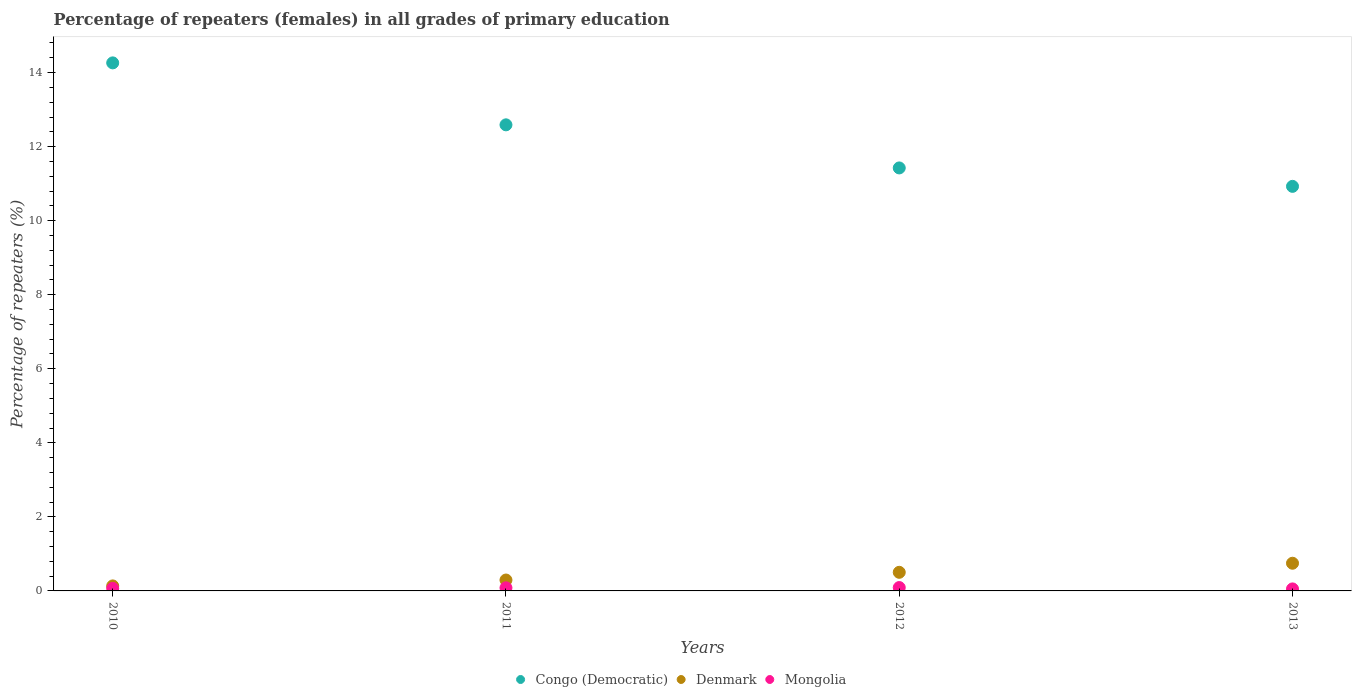Is the number of dotlines equal to the number of legend labels?
Offer a terse response. Yes. What is the percentage of repeaters (females) in Congo (Democratic) in 2011?
Your response must be concise. 12.59. Across all years, what is the maximum percentage of repeaters (females) in Mongolia?
Offer a very short reply. 0.09. Across all years, what is the minimum percentage of repeaters (females) in Mongolia?
Your answer should be compact. 0.05. In which year was the percentage of repeaters (females) in Denmark maximum?
Your answer should be very brief. 2013. What is the total percentage of repeaters (females) in Denmark in the graph?
Ensure brevity in your answer.  1.68. What is the difference between the percentage of repeaters (females) in Mongolia in 2012 and that in 2013?
Ensure brevity in your answer.  0.04. What is the difference between the percentage of repeaters (females) in Denmark in 2011 and the percentage of repeaters (females) in Mongolia in 2012?
Keep it short and to the point. 0.2. What is the average percentage of repeaters (females) in Mongolia per year?
Give a very brief answer. 0.07. In the year 2011, what is the difference between the percentage of repeaters (females) in Mongolia and percentage of repeaters (females) in Denmark?
Your answer should be compact. -0.21. What is the ratio of the percentage of repeaters (females) in Denmark in 2012 to that in 2013?
Give a very brief answer. 0.67. Is the percentage of repeaters (females) in Denmark in 2012 less than that in 2013?
Make the answer very short. Yes. Is the difference between the percentage of repeaters (females) in Mongolia in 2010 and 2013 greater than the difference between the percentage of repeaters (females) in Denmark in 2010 and 2013?
Your answer should be very brief. Yes. What is the difference between the highest and the second highest percentage of repeaters (females) in Mongolia?
Keep it short and to the point. 0.01. What is the difference between the highest and the lowest percentage of repeaters (females) in Mongolia?
Give a very brief answer. 0.04. Is the sum of the percentage of repeaters (females) in Denmark in 2010 and 2011 greater than the maximum percentage of repeaters (females) in Congo (Democratic) across all years?
Your answer should be very brief. No. Is it the case that in every year, the sum of the percentage of repeaters (females) in Denmark and percentage of repeaters (females) in Congo (Democratic)  is greater than the percentage of repeaters (females) in Mongolia?
Provide a succinct answer. Yes. Does the percentage of repeaters (females) in Mongolia monotonically increase over the years?
Provide a succinct answer. No. Is the percentage of repeaters (females) in Congo (Democratic) strictly less than the percentage of repeaters (females) in Mongolia over the years?
Your response must be concise. No. How many years are there in the graph?
Offer a terse response. 4. Are the values on the major ticks of Y-axis written in scientific E-notation?
Give a very brief answer. No. Does the graph contain grids?
Your response must be concise. No. How many legend labels are there?
Provide a succinct answer. 3. How are the legend labels stacked?
Your answer should be very brief. Horizontal. What is the title of the graph?
Offer a very short reply. Percentage of repeaters (females) in all grades of primary education. Does "Panama" appear as one of the legend labels in the graph?
Ensure brevity in your answer.  No. What is the label or title of the Y-axis?
Keep it short and to the point. Percentage of repeaters (%). What is the Percentage of repeaters (%) of Congo (Democratic) in 2010?
Your answer should be compact. 14.26. What is the Percentage of repeaters (%) in Denmark in 2010?
Provide a succinct answer. 0.14. What is the Percentage of repeaters (%) of Mongolia in 2010?
Provide a short and direct response. 0.07. What is the Percentage of repeaters (%) in Congo (Democratic) in 2011?
Your answer should be compact. 12.59. What is the Percentage of repeaters (%) of Denmark in 2011?
Offer a very short reply. 0.29. What is the Percentage of repeaters (%) of Mongolia in 2011?
Your answer should be very brief. 0.08. What is the Percentage of repeaters (%) in Congo (Democratic) in 2012?
Keep it short and to the point. 11.43. What is the Percentage of repeaters (%) in Denmark in 2012?
Keep it short and to the point. 0.5. What is the Percentage of repeaters (%) of Mongolia in 2012?
Your answer should be compact. 0.09. What is the Percentage of repeaters (%) in Congo (Democratic) in 2013?
Your answer should be compact. 10.93. What is the Percentage of repeaters (%) in Denmark in 2013?
Ensure brevity in your answer.  0.75. What is the Percentage of repeaters (%) of Mongolia in 2013?
Make the answer very short. 0.05. Across all years, what is the maximum Percentage of repeaters (%) in Congo (Democratic)?
Your answer should be very brief. 14.26. Across all years, what is the maximum Percentage of repeaters (%) of Denmark?
Ensure brevity in your answer.  0.75. Across all years, what is the maximum Percentage of repeaters (%) of Mongolia?
Offer a very short reply. 0.09. Across all years, what is the minimum Percentage of repeaters (%) in Congo (Democratic)?
Provide a short and direct response. 10.93. Across all years, what is the minimum Percentage of repeaters (%) in Denmark?
Provide a succinct answer. 0.14. Across all years, what is the minimum Percentage of repeaters (%) in Mongolia?
Your response must be concise. 0.05. What is the total Percentage of repeaters (%) in Congo (Democratic) in the graph?
Give a very brief answer. 49.21. What is the total Percentage of repeaters (%) of Denmark in the graph?
Keep it short and to the point. 1.68. What is the total Percentage of repeaters (%) in Mongolia in the graph?
Make the answer very short. 0.3. What is the difference between the Percentage of repeaters (%) in Congo (Democratic) in 2010 and that in 2011?
Provide a short and direct response. 1.67. What is the difference between the Percentage of repeaters (%) in Denmark in 2010 and that in 2011?
Make the answer very short. -0.16. What is the difference between the Percentage of repeaters (%) of Mongolia in 2010 and that in 2011?
Make the answer very short. -0.02. What is the difference between the Percentage of repeaters (%) in Congo (Democratic) in 2010 and that in 2012?
Offer a terse response. 2.84. What is the difference between the Percentage of repeaters (%) of Denmark in 2010 and that in 2012?
Provide a short and direct response. -0.37. What is the difference between the Percentage of repeaters (%) in Mongolia in 2010 and that in 2012?
Ensure brevity in your answer.  -0.02. What is the difference between the Percentage of repeaters (%) in Congo (Democratic) in 2010 and that in 2013?
Your response must be concise. 3.34. What is the difference between the Percentage of repeaters (%) of Denmark in 2010 and that in 2013?
Your answer should be very brief. -0.61. What is the difference between the Percentage of repeaters (%) of Mongolia in 2010 and that in 2013?
Offer a very short reply. 0.01. What is the difference between the Percentage of repeaters (%) in Congo (Democratic) in 2011 and that in 2012?
Offer a terse response. 1.16. What is the difference between the Percentage of repeaters (%) of Denmark in 2011 and that in 2012?
Give a very brief answer. -0.21. What is the difference between the Percentage of repeaters (%) of Mongolia in 2011 and that in 2012?
Make the answer very short. -0.01. What is the difference between the Percentage of repeaters (%) of Congo (Democratic) in 2011 and that in 2013?
Your answer should be compact. 1.66. What is the difference between the Percentage of repeaters (%) in Denmark in 2011 and that in 2013?
Your answer should be very brief. -0.45. What is the difference between the Percentage of repeaters (%) of Mongolia in 2011 and that in 2013?
Offer a very short reply. 0.03. What is the difference between the Percentage of repeaters (%) of Congo (Democratic) in 2012 and that in 2013?
Your response must be concise. 0.5. What is the difference between the Percentage of repeaters (%) in Denmark in 2012 and that in 2013?
Provide a short and direct response. -0.24. What is the difference between the Percentage of repeaters (%) in Mongolia in 2012 and that in 2013?
Your response must be concise. 0.04. What is the difference between the Percentage of repeaters (%) of Congo (Democratic) in 2010 and the Percentage of repeaters (%) of Denmark in 2011?
Give a very brief answer. 13.97. What is the difference between the Percentage of repeaters (%) of Congo (Democratic) in 2010 and the Percentage of repeaters (%) of Mongolia in 2011?
Give a very brief answer. 14.18. What is the difference between the Percentage of repeaters (%) of Denmark in 2010 and the Percentage of repeaters (%) of Mongolia in 2011?
Keep it short and to the point. 0.05. What is the difference between the Percentage of repeaters (%) in Congo (Democratic) in 2010 and the Percentage of repeaters (%) in Denmark in 2012?
Offer a terse response. 13.76. What is the difference between the Percentage of repeaters (%) of Congo (Democratic) in 2010 and the Percentage of repeaters (%) of Mongolia in 2012?
Ensure brevity in your answer.  14.17. What is the difference between the Percentage of repeaters (%) in Denmark in 2010 and the Percentage of repeaters (%) in Mongolia in 2012?
Your response must be concise. 0.04. What is the difference between the Percentage of repeaters (%) in Congo (Democratic) in 2010 and the Percentage of repeaters (%) in Denmark in 2013?
Your answer should be compact. 13.52. What is the difference between the Percentage of repeaters (%) of Congo (Democratic) in 2010 and the Percentage of repeaters (%) of Mongolia in 2013?
Your response must be concise. 14.21. What is the difference between the Percentage of repeaters (%) of Denmark in 2010 and the Percentage of repeaters (%) of Mongolia in 2013?
Your answer should be compact. 0.08. What is the difference between the Percentage of repeaters (%) in Congo (Democratic) in 2011 and the Percentage of repeaters (%) in Denmark in 2012?
Make the answer very short. 12.09. What is the difference between the Percentage of repeaters (%) in Congo (Democratic) in 2011 and the Percentage of repeaters (%) in Mongolia in 2012?
Your answer should be very brief. 12.5. What is the difference between the Percentage of repeaters (%) of Denmark in 2011 and the Percentage of repeaters (%) of Mongolia in 2012?
Your answer should be very brief. 0.2. What is the difference between the Percentage of repeaters (%) of Congo (Democratic) in 2011 and the Percentage of repeaters (%) of Denmark in 2013?
Offer a terse response. 11.84. What is the difference between the Percentage of repeaters (%) of Congo (Democratic) in 2011 and the Percentage of repeaters (%) of Mongolia in 2013?
Your answer should be very brief. 12.54. What is the difference between the Percentage of repeaters (%) of Denmark in 2011 and the Percentage of repeaters (%) of Mongolia in 2013?
Your response must be concise. 0.24. What is the difference between the Percentage of repeaters (%) in Congo (Democratic) in 2012 and the Percentage of repeaters (%) in Denmark in 2013?
Your answer should be very brief. 10.68. What is the difference between the Percentage of repeaters (%) in Congo (Democratic) in 2012 and the Percentage of repeaters (%) in Mongolia in 2013?
Keep it short and to the point. 11.37. What is the difference between the Percentage of repeaters (%) in Denmark in 2012 and the Percentage of repeaters (%) in Mongolia in 2013?
Your response must be concise. 0.45. What is the average Percentage of repeaters (%) of Congo (Democratic) per year?
Offer a very short reply. 12.3. What is the average Percentage of repeaters (%) of Denmark per year?
Keep it short and to the point. 0.42. What is the average Percentage of repeaters (%) in Mongolia per year?
Offer a very short reply. 0.07. In the year 2010, what is the difference between the Percentage of repeaters (%) in Congo (Democratic) and Percentage of repeaters (%) in Denmark?
Provide a succinct answer. 14.13. In the year 2010, what is the difference between the Percentage of repeaters (%) of Congo (Democratic) and Percentage of repeaters (%) of Mongolia?
Your answer should be very brief. 14.19. In the year 2010, what is the difference between the Percentage of repeaters (%) in Denmark and Percentage of repeaters (%) in Mongolia?
Keep it short and to the point. 0.07. In the year 2011, what is the difference between the Percentage of repeaters (%) in Congo (Democratic) and Percentage of repeaters (%) in Denmark?
Your answer should be very brief. 12.29. In the year 2011, what is the difference between the Percentage of repeaters (%) in Congo (Democratic) and Percentage of repeaters (%) in Mongolia?
Keep it short and to the point. 12.51. In the year 2011, what is the difference between the Percentage of repeaters (%) of Denmark and Percentage of repeaters (%) of Mongolia?
Your response must be concise. 0.21. In the year 2012, what is the difference between the Percentage of repeaters (%) in Congo (Democratic) and Percentage of repeaters (%) in Denmark?
Offer a terse response. 10.92. In the year 2012, what is the difference between the Percentage of repeaters (%) in Congo (Democratic) and Percentage of repeaters (%) in Mongolia?
Your answer should be compact. 11.33. In the year 2012, what is the difference between the Percentage of repeaters (%) of Denmark and Percentage of repeaters (%) of Mongolia?
Keep it short and to the point. 0.41. In the year 2013, what is the difference between the Percentage of repeaters (%) in Congo (Democratic) and Percentage of repeaters (%) in Denmark?
Make the answer very short. 10.18. In the year 2013, what is the difference between the Percentage of repeaters (%) in Congo (Democratic) and Percentage of repeaters (%) in Mongolia?
Offer a very short reply. 10.87. In the year 2013, what is the difference between the Percentage of repeaters (%) of Denmark and Percentage of repeaters (%) of Mongolia?
Offer a terse response. 0.69. What is the ratio of the Percentage of repeaters (%) of Congo (Democratic) in 2010 to that in 2011?
Give a very brief answer. 1.13. What is the ratio of the Percentage of repeaters (%) in Denmark in 2010 to that in 2011?
Your answer should be compact. 0.46. What is the ratio of the Percentage of repeaters (%) of Mongolia in 2010 to that in 2011?
Ensure brevity in your answer.  0.82. What is the ratio of the Percentage of repeaters (%) in Congo (Democratic) in 2010 to that in 2012?
Your answer should be very brief. 1.25. What is the ratio of the Percentage of repeaters (%) of Denmark in 2010 to that in 2012?
Keep it short and to the point. 0.27. What is the ratio of the Percentage of repeaters (%) in Mongolia in 2010 to that in 2012?
Give a very brief answer. 0.75. What is the ratio of the Percentage of repeaters (%) in Congo (Democratic) in 2010 to that in 2013?
Provide a short and direct response. 1.31. What is the ratio of the Percentage of repeaters (%) of Denmark in 2010 to that in 2013?
Make the answer very short. 0.18. What is the ratio of the Percentage of repeaters (%) of Mongolia in 2010 to that in 2013?
Your answer should be compact. 1.26. What is the ratio of the Percentage of repeaters (%) in Congo (Democratic) in 2011 to that in 2012?
Give a very brief answer. 1.1. What is the ratio of the Percentage of repeaters (%) of Denmark in 2011 to that in 2012?
Keep it short and to the point. 0.59. What is the ratio of the Percentage of repeaters (%) in Mongolia in 2011 to that in 2012?
Ensure brevity in your answer.  0.92. What is the ratio of the Percentage of repeaters (%) in Congo (Democratic) in 2011 to that in 2013?
Provide a short and direct response. 1.15. What is the ratio of the Percentage of repeaters (%) of Denmark in 2011 to that in 2013?
Provide a short and direct response. 0.39. What is the ratio of the Percentage of repeaters (%) of Mongolia in 2011 to that in 2013?
Provide a short and direct response. 1.54. What is the ratio of the Percentage of repeaters (%) of Congo (Democratic) in 2012 to that in 2013?
Offer a terse response. 1.05. What is the ratio of the Percentage of repeaters (%) of Denmark in 2012 to that in 2013?
Keep it short and to the point. 0.67. What is the ratio of the Percentage of repeaters (%) of Mongolia in 2012 to that in 2013?
Provide a succinct answer. 1.68. What is the difference between the highest and the second highest Percentage of repeaters (%) in Congo (Democratic)?
Keep it short and to the point. 1.67. What is the difference between the highest and the second highest Percentage of repeaters (%) in Denmark?
Your answer should be very brief. 0.24. What is the difference between the highest and the second highest Percentage of repeaters (%) in Mongolia?
Your answer should be very brief. 0.01. What is the difference between the highest and the lowest Percentage of repeaters (%) of Congo (Democratic)?
Keep it short and to the point. 3.34. What is the difference between the highest and the lowest Percentage of repeaters (%) of Denmark?
Your response must be concise. 0.61. What is the difference between the highest and the lowest Percentage of repeaters (%) of Mongolia?
Provide a short and direct response. 0.04. 